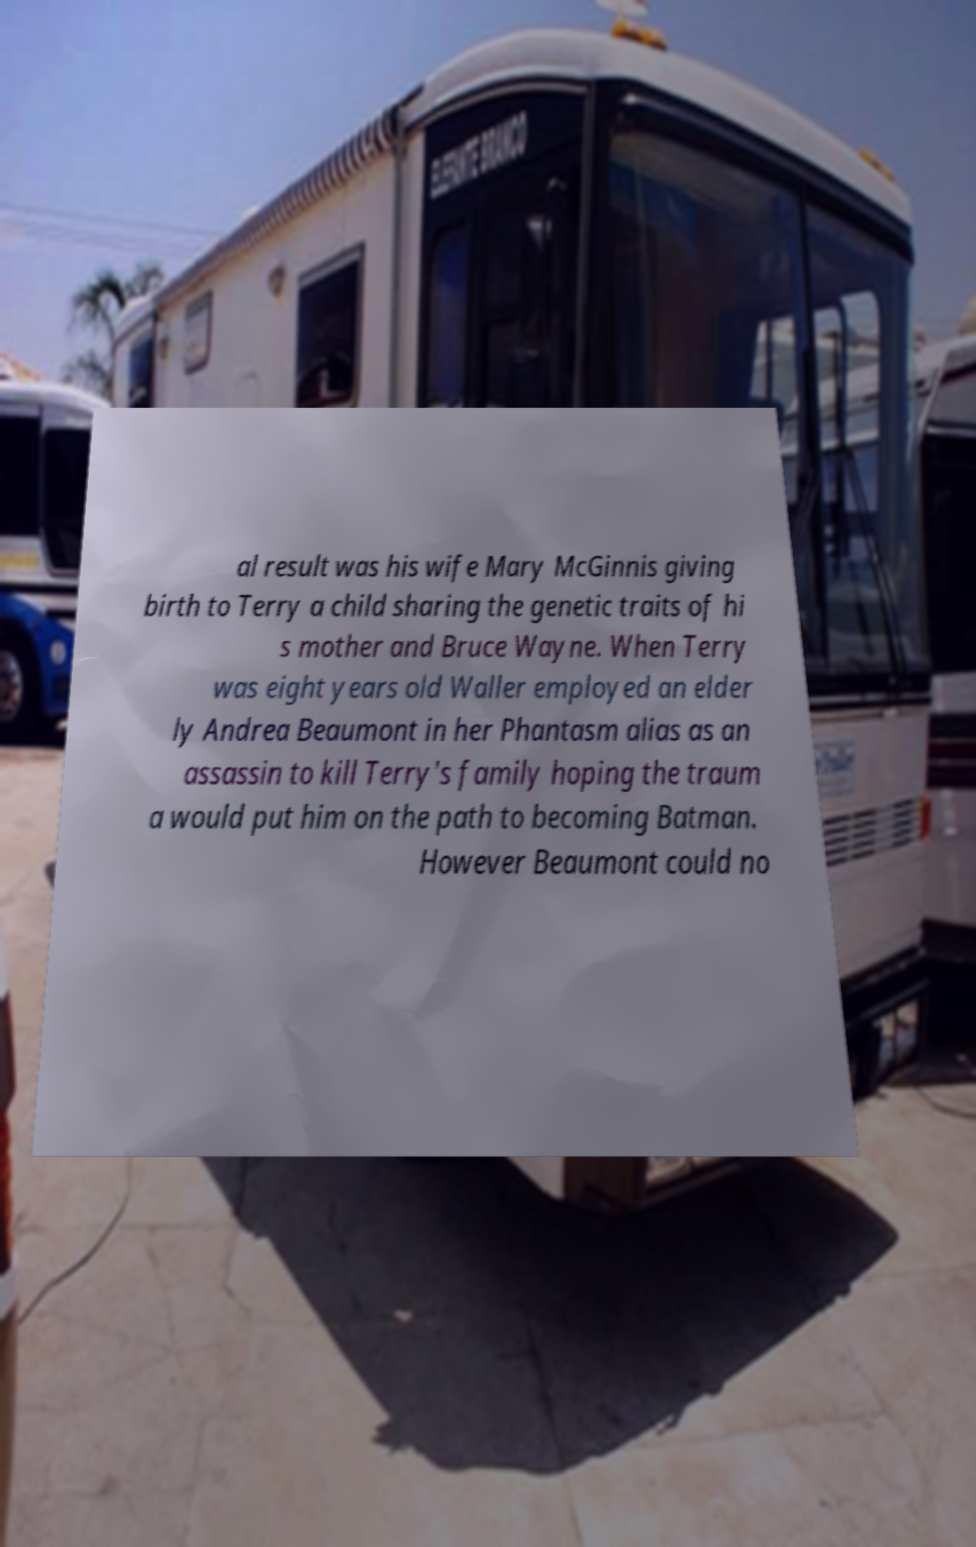For documentation purposes, I need the text within this image transcribed. Could you provide that? al result was his wife Mary McGinnis giving birth to Terry a child sharing the genetic traits of hi s mother and Bruce Wayne. When Terry was eight years old Waller employed an elder ly Andrea Beaumont in her Phantasm alias as an assassin to kill Terry's family hoping the traum a would put him on the path to becoming Batman. However Beaumont could no 